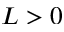Convert formula to latex. <formula><loc_0><loc_0><loc_500><loc_500>L > 0</formula> 